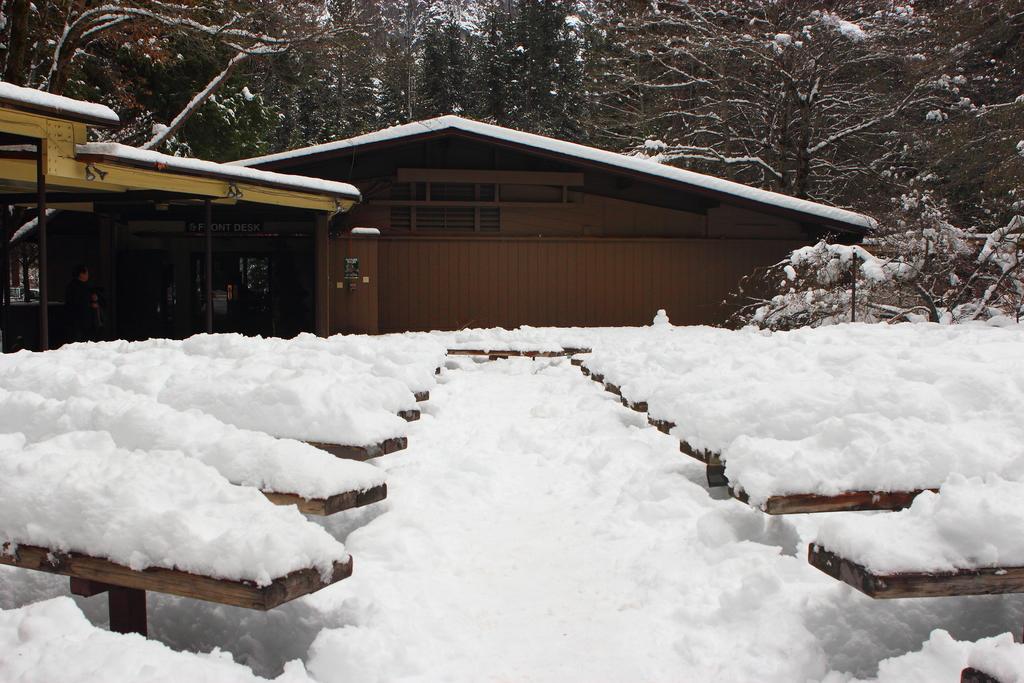Could you give a brief overview of what you see in this image? In this picture, it seems to be there are benches on the right and left side of the image, which are covered with snow and there are trees and a house in the background area of the image. 